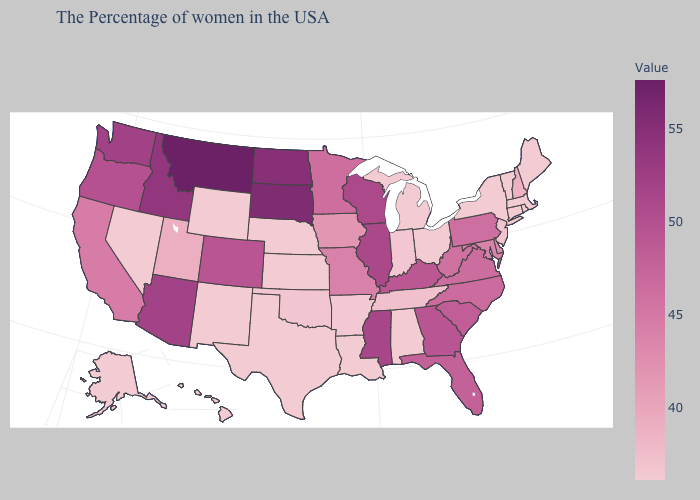Among the states that border Maryland , does West Virginia have the lowest value?
Keep it brief. No. Does Louisiana have a lower value than Utah?
Answer briefly. Yes. Among the states that border Indiana , which have the highest value?
Concise answer only. Illinois. Does Alaska have the lowest value in the USA?
Be succinct. Yes. Does California have the lowest value in the West?
Quick response, please. No. Does the map have missing data?
Short answer required. No. Does Oregon have a higher value than Washington?
Be succinct. No. Which states have the lowest value in the Northeast?
Give a very brief answer. Maine, Massachusetts, Rhode Island, Vermont, Connecticut, New York. 